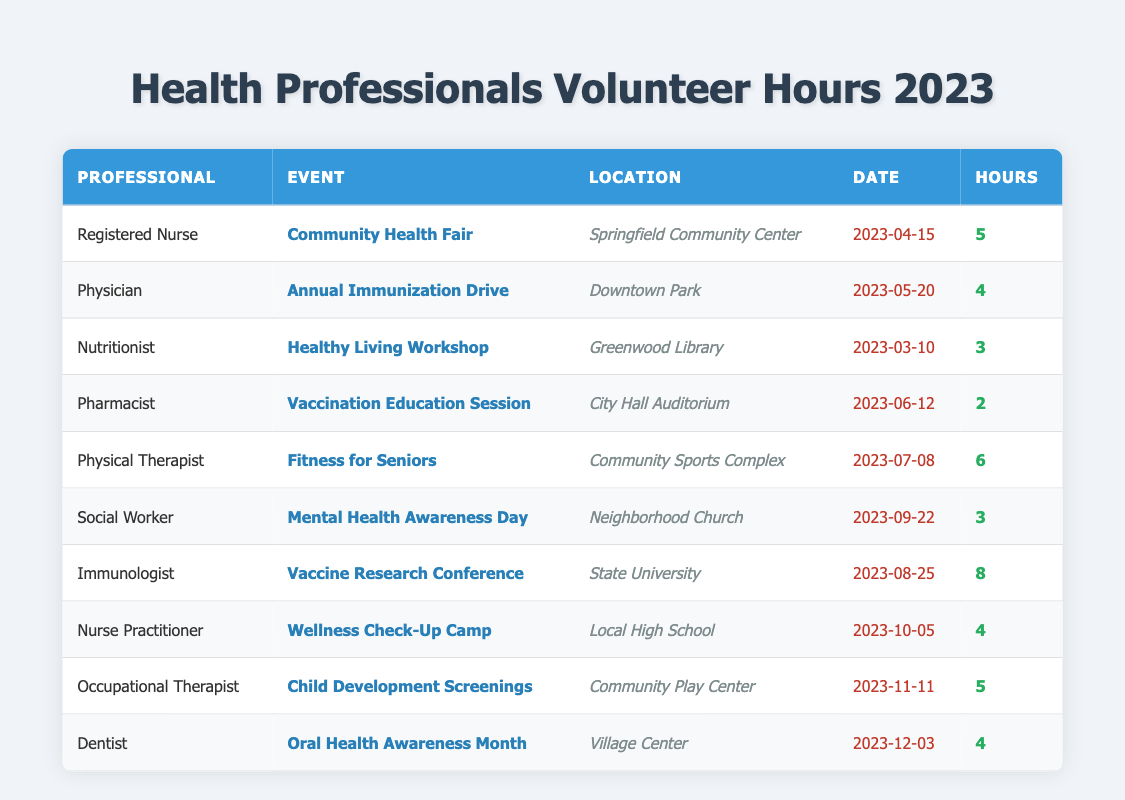What event did the registered nurse volunteer for? The table lists the events for each professional. By locating "Registered Nurse" in the Professional column, we find "Community Health Fair" in the Event column for that entry.
Answer: Community Health Fair How many hours did the immunologist contribute in total? The immunologist's entry shows 8 hours for the "Vaccine Research Conference" event. Since it’s the only entry, the total is simply 8 hours.
Answer: 8 Which professional volunteered for the most hours? By examining the Hours column, we identify the highest value is 8 hours contributed by the immunologist. Comparing with others, no one has more hours.
Answer: Immunologist What is the average number of hours volunteered by all professionals? To calculate the average, we sum the hours: (5 + 4 + 3 + 2 + 6 + 3 + 8 + 4 + 5 + 4) = 44. There are 10 professionals, so the average is 44/10 = 4.4.
Answer: 4.4 Did any professional volunteer for exactly 3 hours? Checking the Hours column, we see that both the Nutritionist and the Social Worker each volunteered 3 hours, confirming the answer is yes.
Answer: Yes Which event took place at the Downtown Park? The table indicates the event held at Downtown Park is listed next to the Physician in the Event column, specifically "Annual Immunization Drive."
Answer: Annual Immunization Drive How many professionals volunteered at events in June? Looking for entries dated in June, we find the Pharmacist's event on June 12 and count this as one professional. There's only one entry for June.
Answer: 1 What was the location of the "Fitness for Seniors" event? The event "Fitness for Seniors" corresponds to the Physical Therapist entry, and its location is listed as "Community Sports Complex."
Answer: Community Sports Complex How many total volunteer hours were contributed by health professionals in September and October? The entries for September (Social Worker, 3 hours) and October (Nurse Practitioner, 4 hours) give us a total of 3 + 4 = 7 hours.
Answer: 7 Is there any professional who volunteered for less than 3 hours? By inspecting the Hours column, the smallest entry is 2 hours (Pharmacist). Thus, the answer is yes.
Answer: Yes Which location had events in both April and November? By looking through the locations for the events in April (Springfield Community Center) and November (Community Play Center), we check for matches and find none.
Answer: None 